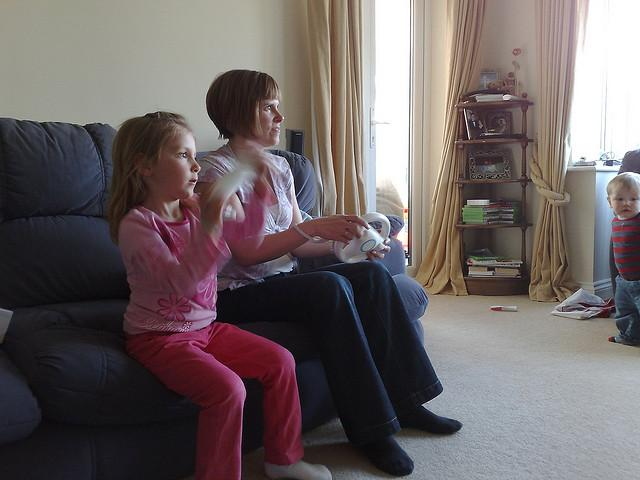What are the people on the couch looking at? Please explain your reasoning. gaming screen. They are playing a game. 